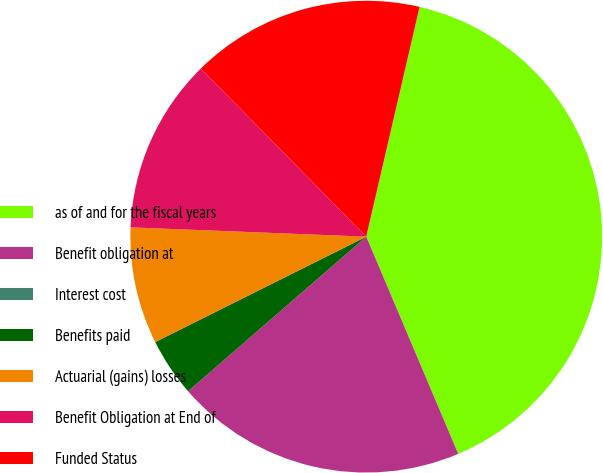Convert chart to OTSL. <chart><loc_0><loc_0><loc_500><loc_500><pie_chart><fcel>as of and for the fiscal years<fcel>Benefit obligation at<fcel>Interest cost<fcel>Benefits paid<fcel>Actuarial (gains) losses<fcel>Benefit Obligation at End of<fcel>Funded Status<nl><fcel>39.99%<fcel>20.0%<fcel>0.0%<fcel>4.0%<fcel>8.0%<fcel>12.0%<fcel>16.0%<nl></chart> 